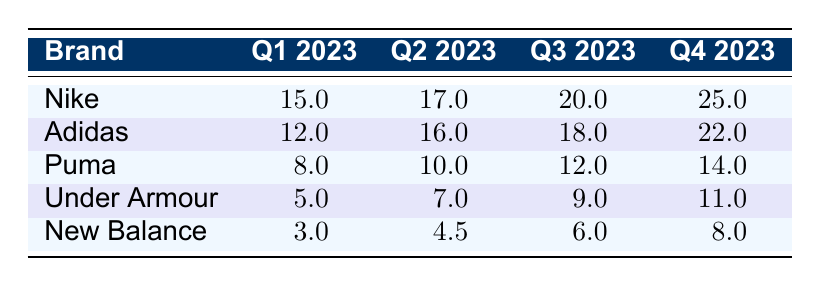What was Nike's sales in Q3 2023? Nike's sales in Q3 2023 can be found in the table under the Q3 2023 column for the Nike row, which shows a value of 20 million.
Answer: 20 million Which brand had the lowest sales in Q1 2023? Looking at the table, the sales figures for Q1 2023 show that New Balance had the lowest sales of 3 million.
Answer: New Balance What is the total sales of Under Armour for all quarters combined? To find the total for Under Armour, we need to add up the sales from each quarter: 5 million + 7 million + 9 million + 11 million = 32 million.
Answer: 32 million How much did Adidas earn more than Puma in Q4 2023? In Q4 2023, Adidas earned 22 million and Puma earned 14 million. The difference is 22 million - 14 million = 8 million.
Answer: 8 million Which brand saw the largest increase in sales from Q1 to Q4 2023? To determine which brand had the largest increase, we calculate the difference in sales from Q1 to Q4 for each brand: Nike (25M - 15M = 10M), Adidas (22M - 12M = 10M), Puma (14M - 8M = 6M), Under Armour (11M - 5M = 6M), New Balance (8M - 3M = 5M). Nike and Adidas both had the largest increase of 10 million.
Answer: Nike and Adidas What is the average sales for Puma across all quarters? To find the average, we sum Puma's sales for all quarters (8 million + 10 million + 12 million + 14 million = 44 million) and divide by the number of quarters (4), yielding an average of 11 million.
Answer: 11 million Did any brand have higher sales in Q3 than in Q4 2023? By inspecting the Q3 and Q4 sales for each brand, it is clear that all brands had higher sales in Q4 than in Q3; thus, the answer is no.
Answer: No What percentage growth did New Balance experience from Q1 to Q4 2023? To calculate the percentage growth for New Balance from Q1 to Q4, we find the difference in sales (8 million - 3 million = 5 million), then divide by Q1 sales (5 million / 3 million) and multiply by 100. This results in approximately 166.67% growth.
Answer: 166.67% Which brand consistently had lower sales than both Nike and Adidas in all quarters? By reviewing the table, it is evident that Under Armour had lower sales than both Nike and Adidas in every quarter listed.
Answer: Under Armour What is the difference in total sales between Nike and New Balance for all quarters? The total sales for Nike are 15 million + 17 million + 20 million + 25 million = 77 million. For New Balance, it’s 3 million + 4.5 million + 6 million + 8 million = 21.5 million. The difference is 77 million - 21.5 million = 55.5 million.
Answer: 55.5 million 